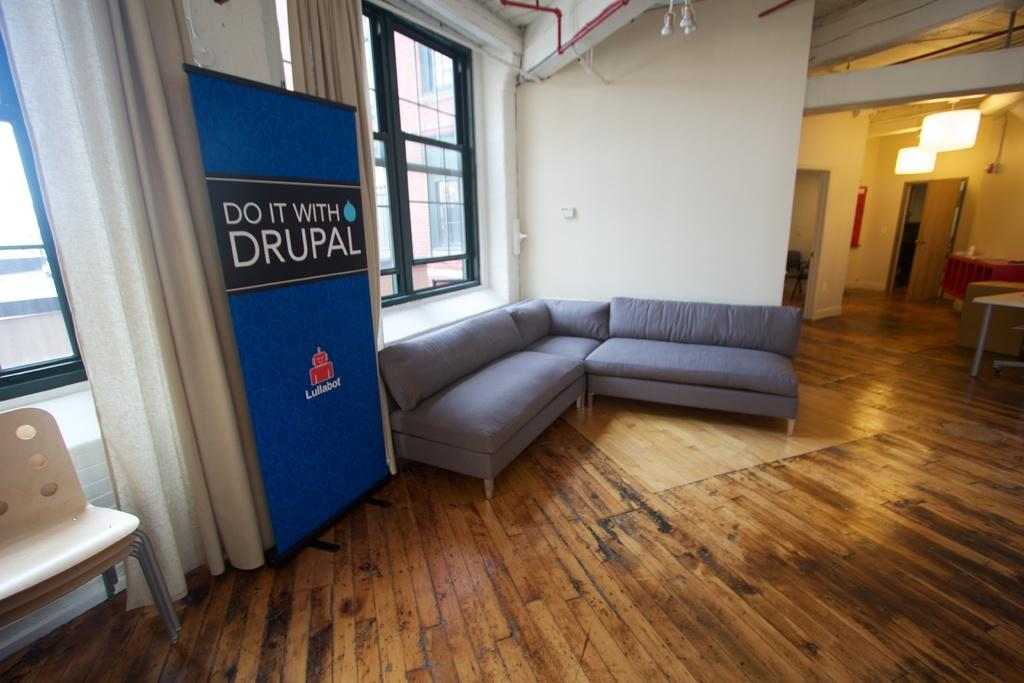What type of furniture is visible in the image? There are chairs and sofas in the image. What other piece of furniture can be seen in the image? There is a table in the image. What can be seen in the background of the image? There are lights, another chair, a door, and curtains in the background of the image. What additional item is present in the image? There is a banner in the image. Can you tell me how many sheep are visible in the image? There are no sheep present in the image. What type of sport is being played by the grandmother in the image? There is no grandmother or any sport being played in the image. 